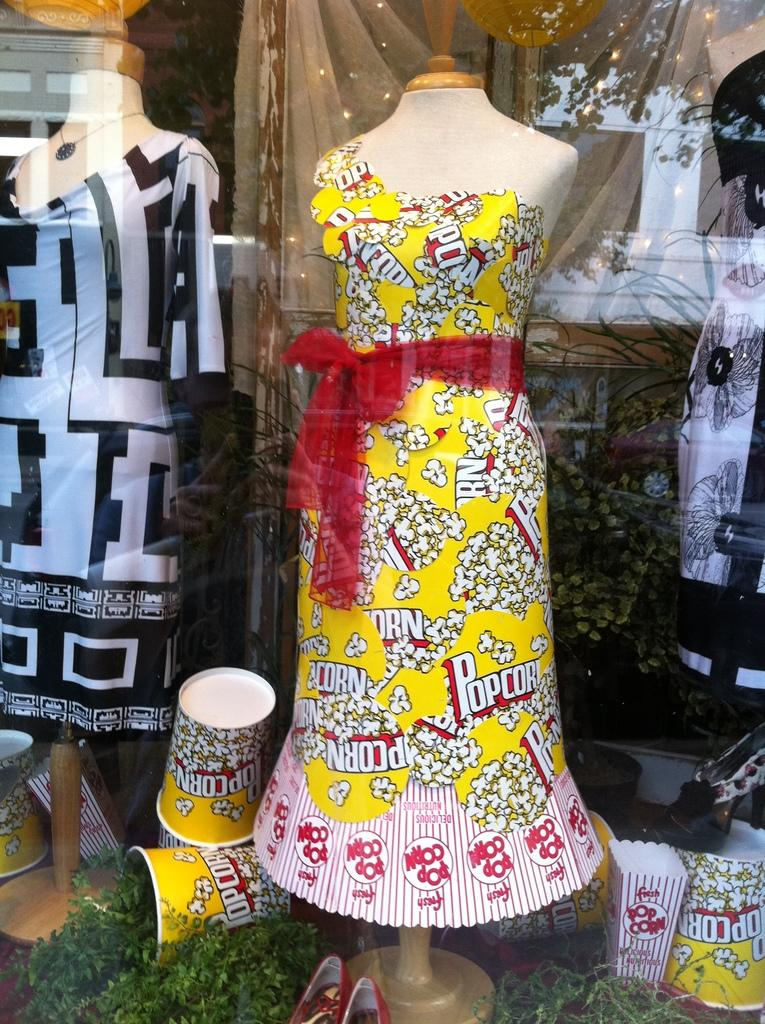What type of figures can be seen in the image? There are mannequins in the image. What are the mannequins wearing? Clothes are placed on the mannequins. What type of containers are visible in the image? There are cups in the image. What type of covering is present in the image? There is a curtain in the image. What type of natural elements can be seen at the bottom of the image? Leaves are present at the bottom of the image. What type of disease is affecting the mannequins in the image? There is no indication of any disease affecting the mannequins in the image; they are simply displaying clothes. 